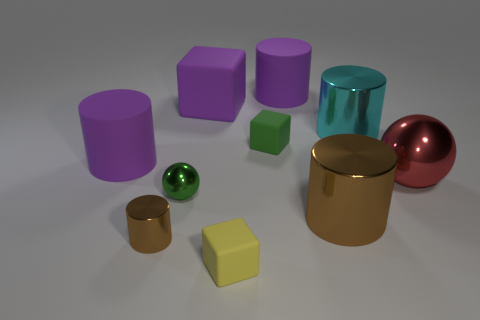How many purple cylinders must be subtracted to get 1 purple cylinders? 1 Subtract all cyan cylinders. How many cylinders are left? 4 Subtract all tiny cylinders. How many cylinders are left? 4 Subtract all blue cylinders. Subtract all green balls. How many cylinders are left? 5 Subtract all spheres. How many objects are left? 8 Add 4 small brown objects. How many small brown objects exist? 5 Subtract 2 brown cylinders. How many objects are left? 8 Subtract all tiny metallic cubes. Subtract all large purple matte cubes. How many objects are left? 9 Add 6 large red balls. How many large red balls are left? 7 